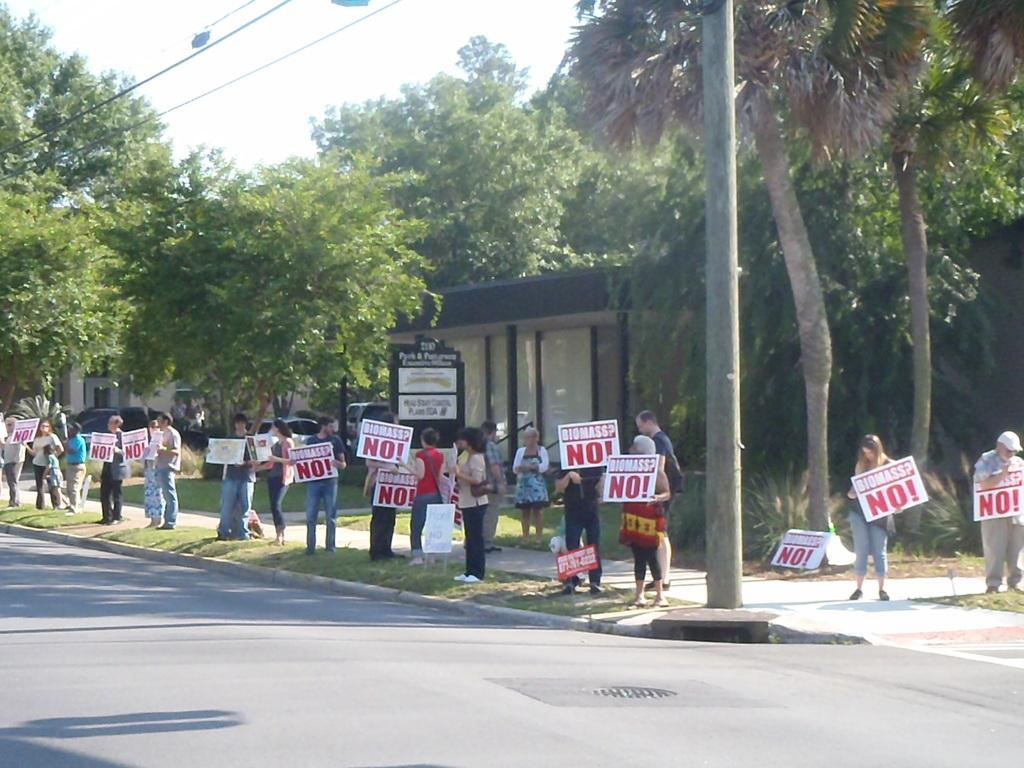Provide a one-sentence caption for the provided image. Group of people protesting with signs saying biomass No!. 